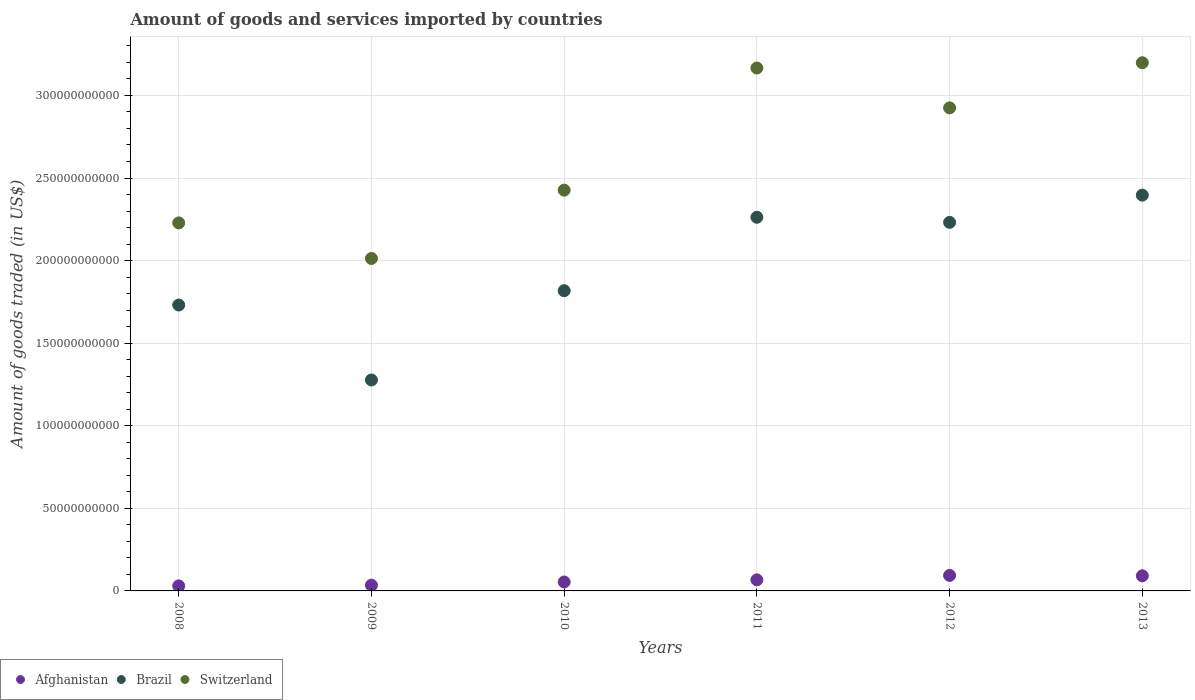Is the number of dotlines equal to the number of legend labels?
Offer a very short reply. Yes. What is the total amount of goods and services imported in Switzerland in 2013?
Provide a short and direct response. 3.20e+11. Across all years, what is the maximum total amount of goods and services imported in Brazil?
Offer a terse response. 2.40e+11. Across all years, what is the minimum total amount of goods and services imported in Brazil?
Make the answer very short. 1.28e+11. In which year was the total amount of goods and services imported in Afghanistan maximum?
Keep it short and to the point. 2012. In which year was the total amount of goods and services imported in Switzerland minimum?
Offer a terse response. 2009. What is the total total amount of goods and services imported in Brazil in the graph?
Your response must be concise. 1.17e+12. What is the difference between the total amount of goods and services imported in Afghanistan in 2009 and that in 2011?
Your answer should be very brief. -3.24e+09. What is the difference between the total amount of goods and services imported in Afghanistan in 2011 and the total amount of goods and services imported in Switzerland in 2008?
Give a very brief answer. -2.16e+11. What is the average total amount of goods and services imported in Switzerland per year?
Keep it short and to the point. 2.66e+11. In the year 2009, what is the difference between the total amount of goods and services imported in Switzerland and total amount of goods and services imported in Afghanistan?
Provide a short and direct response. 1.98e+11. In how many years, is the total amount of goods and services imported in Switzerland greater than 130000000000 US$?
Provide a succinct answer. 6. What is the ratio of the total amount of goods and services imported in Afghanistan in 2008 to that in 2013?
Make the answer very short. 0.33. Is the total amount of goods and services imported in Afghanistan in 2010 less than that in 2012?
Make the answer very short. Yes. Is the difference between the total amount of goods and services imported in Switzerland in 2009 and 2013 greater than the difference between the total amount of goods and services imported in Afghanistan in 2009 and 2013?
Your answer should be compact. No. What is the difference between the highest and the second highest total amount of goods and services imported in Brazil?
Ensure brevity in your answer.  1.34e+1. What is the difference between the highest and the lowest total amount of goods and services imported in Afghanistan?
Offer a very short reply. 6.35e+09. Is the sum of the total amount of goods and services imported in Afghanistan in 2009 and 2013 greater than the maximum total amount of goods and services imported in Brazil across all years?
Your response must be concise. No. Does the total amount of goods and services imported in Afghanistan monotonically increase over the years?
Your answer should be very brief. No. How many dotlines are there?
Give a very brief answer. 3. How many years are there in the graph?
Keep it short and to the point. 6. Does the graph contain any zero values?
Offer a very short reply. No. How many legend labels are there?
Offer a very short reply. 3. How are the legend labels stacked?
Provide a short and direct response. Horizontal. What is the title of the graph?
Your response must be concise. Amount of goods and services imported by countries. What is the label or title of the X-axis?
Make the answer very short. Years. What is the label or title of the Y-axis?
Make the answer very short. Amount of goods traded (in US$). What is the Amount of goods traded (in US$) in Afghanistan in 2008?
Provide a succinct answer. 3.04e+09. What is the Amount of goods traded (in US$) in Brazil in 2008?
Your answer should be compact. 1.73e+11. What is the Amount of goods traded (in US$) in Switzerland in 2008?
Offer a terse response. 2.23e+11. What is the Amount of goods traded (in US$) of Afghanistan in 2009?
Ensure brevity in your answer.  3.47e+09. What is the Amount of goods traded (in US$) of Brazil in 2009?
Make the answer very short. 1.28e+11. What is the Amount of goods traded (in US$) in Switzerland in 2009?
Your answer should be very brief. 2.01e+11. What is the Amount of goods traded (in US$) of Afghanistan in 2010?
Provide a succinct answer. 5.40e+09. What is the Amount of goods traded (in US$) in Brazil in 2010?
Offer a very short reply. 1.82e+11. What is the Amount of goods traded (in US$) in Switzerland in 2010?
Keep it short and to the point. 2.43e+11. What is the Amount of goods traded (in US$) in Afghanistan in 2011?
Provide a succinct answer. 6.71e+09. What is the Amount of goods traded (in US$) in Brazil in 2011?
Keep it short and to the point. 2.26e+11. What is the Amount of goods traded (in US$) of Switzerland in 2011?
Provide a succinct answer. 3.17e+11. What is the Amount of goods traded (in US$) in Afghanistan in 2012?
Your answer should be compact. 9.39e+09. What is the Amount of goods traded (in US$) of Brazil in 2012?
Keep it short and to the point. 2.23e+11. What is the Amount of goods traded (in US$) in Switzerland in 2012?
Provide a short and direct response. 2.92e+11. What is the Amount of goods traded (in US$) of Afghanistan in 2013?
Your answer should be compact. 9.15e+09. What is the Amount of goods traded (in US$) of Brazil in 2013?
Make the answer very short. 2.40e+11. What is the Amount of goods traded (in US$) of Switzerland in 2013?
Make the answer very short. 3.20e+11. Across all years, what is the maximum Amount of goods traded (in US$) in Afghanistan?
Give a very brief answer. 9.39e+09. Across all years, what is the maximum Amount of goods traded (in US$) in Brazil?
Give a very brief answer. 2.40e+11. Across all years, what is the maximum Amount of goods traded (in US$) in Switzerland?
Keep it short and to the point. 3.20e+11. Across all years, what is the minimum Amount of goods traded (in US$) in Afghanistan?
Offer a terse response. 3.04e+09. Across all years, what is the minimum Amount of goods traded (in US$) of Brazil?
Provide a short and direct response. 1.28e+11. Across all years, what is the minimum Amount of goods traded (in US$) in Switzerland?
Ensure brevity in your answer.  2.01e+11. What is the total Amount of goods traded (in US$) in Afghanistan in the graph?
Keep it short and to the point. 3.72e+1. What is the total Amount of goods traded (in US$) in Brazil in the graph?
Offer a terse response. 1.17e+12. What is the total Amount of goods traded (in US$) in Switzerland in the graph?
Offer a terse response. 1.60e+12. What is the difference between the Amount of goods traded (in US$) in Afghanistan in 2008 and that in 2009?
Provide a succinct answer. -4.23e+08. What is the difference between the Amount of goods traded (in US$) in Brazil in 2008 and that in 2009?
Offer a terse response. 4.54e+1. What is the difference between the Amount of goods traded (in US$) of Switzerland in 2008 and that in 2009?
Make the answer very short. 2.15e+1. What is the difference between the Amount of goods traded (in US$) of Afghanistan in 2008 and that in 2010?
Give a very brief answer. -2.36e+09. What is the difference between the Amount of goods traded (in US$) in Brazil in 2008 and that in 2010?
Your answer should be compact. -8.66e+09. What is the difference between the Amount of goods traded (in US$) of Switzerland in 2008 and that in 2010?
Ensure brevity in your answer.  -1.98e+1. What is the difference between the Amount of goods traded (in US$) of Afghanistan in 2008 and that in 2011?
Your response must be concise. -3.67e+09. What is the difference between the Amount of goods traded (in US$) of Brazil in 2008 and that in 2011?
Provide a short and direct response. -5.31e+1. What is the difference between the Amount of goods traded (in US$) in Switzerland in 2008 and that in 2011?
Offer a terse response. -9.38e+1. What is the difference between the Amount of goods traded (in US$) in Afghanistan in 2008 and that in 2012?
Keep it short and to the point. -6.35e+09. What is the difference between the Amount of goods traded (in US$) of Brazil in 2008 and that in 2012?
Offer a terse response. -5.00e+1. What is the difference between the Amount of goods traded (in US$) of Switzerland in 2008 and that in 2012?
Ensure brevity in your answer.  -6.96e+1. What is the difference between the Amount of goods traded (in US$) of Afghanistan in 2008 and that in 2013?
Keep it short and to the point. -6.10e+09. What is the difference between the Amount of goods traded (in US$) in Brazil in 2008 and that in 2013?
Your answer should be compact. -6.65e+1. What is the difference between the Amount of goods traded (in US$) of Switzerland in 2008 and that in 2013?
Keep it short and to the point. -9.70e+1. What is the difference between the Amount of goods traded (in US$) of Afghanistan in 2009 and that in 2010?
Make the answer very short. -1.94e+09. What is the difference between the Amount of goods traded (in US$) of Brazil in 2009 and that in 2010?
Your response must be concise. -5.40e+1. What is the difference between the Amount of goods traded (in US$) of Switzerland in 2009 and that in 2010?
Ensure brevity in your answer.  -4.14e+1. What is the difference between the Amount of goods traded (in US$) in Afghanistan in 2009 and that in 2011?
Offer a terse response. -3.24e+09. What is the difference between the Amount of goods traded (in US$) of Brazil in 2009 and that in 2011?
Your response must be concise. -9.85e+1. What is the difference between the Amount of goods traded (in US$) in Switzerland in 2009 and that in 2011?
Your response must be concise. -1.15e+11. What is the difference between the Amount of goods traded (in US$) of Afghanistan in 2009 and that in 2012?
Your answer should be very brief. -5.93e+09. What is the difference between the Amount of goods traded (in US$) of Brazil in 2009 and that in 2012?
Give a very brief answer. -9.54e+1. What is the difference between the Amount of goods traded (in US$) of Switzerland in 2009 and that in 2012?
Ensure brevity in your answer.  -9.12e+1. What is the difference between the Amount of goods traded (in US$) of Afghanistan in 2009 and that in 2013?
Your response must be concise. -5.68e+09. What is the difference between the Amount of goods traded (in US$) of Brazil in 2009 and that in 2013?
Your answer should be compact. -1.12e+11. What is the difference between the Amount of goods traded (in US$) in Switzerland in 2009 and that in 2013?
Your answer should be compact. -1.19e+11. What is the difference between the Amount of goods traded (in US$) of Afghanistan in 2010 and that in 2011?
Keep it short and to the point. -1.31e+09. What is the difference between the Amount of goods traded (in US$) of Brazil in 2010 and that in 2011?
Your response must be concise. -4.45e+1. What is the difference between the Amount of goods traded (in US$) in Switzerland in 2010 and that in 2011?
Keep it short and to the point. -7.39e+1. What is the difference between the Amount of goods traded (in US$) of Afghanistan in 2010 and that in 2012?
Your answer should be very brief. -3.99e+09. What is the difference between the Amount of goods traded (in US$) in Brazil in 2010 and that in 2012?
Give a very brief answer. -4.14e+1. What is the difference between the Amount of goods traded (in US$) in Switzerland in 2010 and that in 2012?
Make the answer very short. -4.98e+1. What is the difference between the Amount of goods traded (in US$) of Afghanistan in 2010 and that in 2013?
Provide a short and direct response. -3.75e+09. What is the difference between the Amount of goods traded (in US$) of Brazil in 2010 and that in 2013?
Give a very brief answer. -5.79e+1. What is the difference between the Amount of goods traded (in US$) of Switzerland in 2010 and that in 2013?
Give a very brief answer. -7.71e+1. What is the difference between the Amount of goods traded (in US$) in Afghanistan in 2011 and that in 2012?
Keep it short and to the point. -2.68e+09. What is the difference between the Amount of goods traded (in US$) of Brazil in 2011 and that in 2012?
Give a very brief answer. 3.08e+09. What is the difference between the Amount of goods traded (in US$) of Switzerland in 2011 and that in 2012?
Provide a succinct answer. 2.41e+1. What is the difference between the Amount of goods traded (in US$) of Afghanistan in 2011 and that in 2013?
Your answer should be very brief. -2.44e+09. What is the difference between the Amount of goods traded (in US$) of Brazil in 2011 and that in 2013?
Your answer should be very brief. -1.34e+1. What is the difference between the Amount of goods traded (in US$) in Switzerland in 2011 and that in 2013?
Offer a very short reply. -3.21e+09. What is the difference between the Amount of goods traded (in US$) of Afghanistan in 2012 and that in 2013?
Your answer should be very brief. 2.47e+08. What is the difference between the Amount of goods traded (in US$) in Brazil in 2012 and that in 2013?
Keep it short and to the point. -1.65e+1. What is the difference between the Amount of goods traded (in US$) in Switzerland in 2012 and that in 2013?
Provide a succinct answer. -2.73e+1. What is the difference between the Amount of goods traded (in US$) in Afghanistan in 2008 and the Amount of goods traded (in US$) in Brazil in 2009?
Ensure brevity in your answer.  -1.25e+11. What is the difference between the Amount of goods traded (in US$) of Afghanistan in 2008 and the Amount of goods traded (in US$) of Switzerland in 2009?
Your answer should be very brief. -1.98e+11. What is the difference between the Amount of goods traded (in US$) of Brazil in 2008 and the Amount of goods traded (in US$) of Switzerland in 2009?
Your answer should be very brief. -2.82e+1. What is the difference between the Amount of goods traded (in US$) of Afghanistan in 2008 and the Amount of goods traded (in US$) of Brazil in 2010?
Offer a terse response. -1.79e+11. What is the difference between the Amount of goods traded (in US$) in Afghanistan in 2008 and the Amount of goods traded (in US$) in Switzerland in 2010?
Provide a short and direct response. -2.40e+11. What is the difference between the Amount of goods traded (in US$) of Brazil in 2008 and the Amount of goods traded (in US$) of Switzerland in 2010?
Make the answer very short. -6.95e+1. What is the difference between the Amount of goods traded (in US$) in Afghanistan in 2008 and the Amount of goods traded (in US$) in Brazil in 2011?
Give a very brief answer. -2.23e+11. What is the difference between the Amount of goods traded (in US$) of Afghanistan in 2008 and the Amount of goods traded (in US$) of Switzerland in 2011?
Offer a very short reply. -3.14e+11. What is the difference between the Amount of goods traded (in US$) in Brazil in 2008 and the Amount of goods traded (in US$) in Switzerland in 2011?
Provide a short and direct response. -1.43e+11. What is the difference between the Amount of goods traded (in US$) in Afghanistan in 2008 and the Amount of goods traded (in US$) in Brazil in 2012?
Offer a terse response. -2.20e+11. What is the difference between the Amount of goods traded (in US$) of Afghanistan in 2008 and the Amount of goods traded (in US$) of Switzerland in 2012?
Make the answer very short. -2.89e+11. What is the difference between the Amount of goods traded (in US$) in Brazil in 2008 and the Amount of goods traded (in US$) in Switzerland in 2012?
Offer a very short reply. -1.19e+11. What is the difference between the Amount of goods traded (in US$) in Afghanistan in 2008 and the Amount of goods traded (in US$) in Brazil in 2013?
Your answer should be very brief. -2.37e+11. What is the difference between the Amount of goods traded (in US$) of Afghanistan in 2008 and the Amount of goods traded (in US$) of Switzerland in 2013?
Your response must be concise. -3.17e+11. What is the difference between the Amount of goods traded (in US$) in Brazil in 2008 and the Amount of goods traded (in US$) in Switzerland in 2013?
Give a very brief answer. -1.47e+11. What is the difference between the Amount of goods traded (in US$) in Afghanistan in 2009 and the Amount of goods traded (in US$) in Brazil in 2010?
Make the answer very short. -1.78e+11. What is the difference between the Amount of goods traded (in US$) in Afghanistan in 2009 and the Amount of goods traded (in US$) in Switzerland in 2010?
Your answer should be compact. -2.39e+11. What is the difference between the Amount of goods traded (in US$) in Brazil in 2009 and the Amount of goods traded (in US$) in Switzerland in 2010?
Make the answer very short. -1.15e+11. What is the difference between the Amount of goods traded (in US$) in Afghanistan in 2009 and the Amount of goods traded (in US$) in Brazil in 2011?
Give a very brief answer. -2.23e+11. What is the difference between the Amount of goods traded (in US$) in Afghanistan in 2009 and the Amount of goods traded (in US$) in Switzerland in 2011?
Keep it short and to the point. -3.13e+11. What is the difference between the Amount of goods traded (in US$) of Brazil in 2009 and the Amount of goods traded (in US$) of Switzerland in 2011?
Make the answer very short. -1.89e+11. What is the difference between the Amount of goods traded (in US$) of Afghanistan in 2009 and the Amount of goods traded (in US$) of Brazil in 2012?
Your response must be concise. -2.20e+11. What is the difference between the Amount of goods traded (in US$) of Afghanistan in 2009 and the Amount of goods traded (in US$) of Switzerland in 2012?
Your answer should be very brief. -2.89e+11. What is the difference between the Amount of goods traded (in US$) in Brazil in 2009 and the Amount of goods traded (in US$) in Switzerland in 2012?
Provide a succinct answer. -1.65e+11. What is the difference between the Amount of goods traded (in US$) in Afghanistan in 2009 and the Amount of goods traded (in US$) in Brazil in 2013?
Keep it short and to the point. -2.36e+11. What is the difference between the Amount of goods traded (in US$) in Afghanistan in 2009 and the Amount of goods traded (in US$) in Switzerland in 2013?
Provide a succinct answer. -3.16e+11. What is the difference between the Amount of goods traded (in US$) in Brazil in 2009 and the Amount of goods traded (in US$) in Switzerland in 2013?
Provide a short and direct response. -1.92e+11. What is the difference between the Amount of goods traded (in US$) of Afghanistan in 2010 and the Amount of goods traded (in US$) of Brazil in 2011?
Provide a short and direct response. -2.21e+11. What is the difference between the Amount of goods traded (in US$) in Afghanistan in 2010 and the Amount of goods traded (in US$) in Switzerland in 2011?
Provide a short and direct response. -3.11e+11. What is the difference between the Amount of goods traded (in US$) in Brazil in 2010 and the Amount of goods traded (in US$) in Switzerland in 2011?
Provide a short and direct response. -1.35e+11. What is the difference between the Amount of goods traded (in US$) in Afghanistan in 2010 and the Amount of goods traded (in US$) in Brazil in 2012?
Offer a very short reply. -2.18e+11. What is the difference between the Amount of goods traded (in US$) in Afghanistan in 2010 and the Amount of goods traded (in US$) in Switzerland in 2012?
Give a very brief answer. -2.87e+11. What is the difference between the Amount of goods traded (in US$) of Brazil in 2010 and the Amount of goods traded (in US$) of Switzerland in 2012?
Your answer should be very brief. -1.11e+11. What is the difference between the Amount of goods traded (in US$) in Afghanistan in 2010 and the Amount of goods traded (in US$) in Brazil in 2013?
Your answer should be very brief. -2.34e+11. What is the difference between the Amount of goods traded (in US$) of Afghanistan in 2010 and the Amount of goods traded (in US$) of Switzerland in 2013?
Ensure brevity in your answer.  -3.14e+11. What is the difference between the Amount of goods traded (in US$) of Brazil in 2010 and the Amount of goods traded (in US$) of Switzerland in 2013?
Offer a terse response. -1.38e+11. What is the difference between the Amount of goods traded (in US$) in Afghanistan in 2011 and the Amount of goods traded (in US$) in Brazil in 2012?
Your answer should be very brief. -2.16e+11. What is the difference between the Amount of goods traded (in US$) of Afghanistan in 2011 and the Amount of goods traded (in US$) of Switzerland in 2012?
Provide a short and direct response. -2.86e+11. What is the difference between the Amount of goods traded (in US$) of Brazil in 2011 and the Amount of goods traded (in US$) of Switzerland in 2012?
Provide a short and direct response. -6.62e+1. What is the difference between the Amount of goods traded (in US$) in Afghanistan in 2011 and the Amount of goods traded (in US$) in Brazil in 2013?
Provide a succinct answer. -2.33e+11. What is the difference between the Amount of goods traded (in US$) in Afghanistan in 2011 and the Amount of goods traded (in US$) in Switzerland in 2013?
Your answer should be very brief. -3.13e+11. What is the difference between the Amount of goods traded (in US$) of Brazil in 2011 and the Amount of goods traded (in US$) of Switzerland in 2013?
Your answer should be very brief. -9.36e+1. What is the difference between the Amount of goods traded (in US$) in Afghanistan in 2012 and the Amount of goods traded (in US$) in Brazil in 2013?
Give a very brief answer. -2.30e+11. What is the difference between the Amount of goods traded (in US$) in Afghanistan in 2012 and the Amount of goods traded (in US$) in Switzerland in 2013?
Make the answer very short. -3.10e+11. What is the difference between the Amount of goods traded (in US$) in Brazil in 2012 and the Amount of goods traded (in US$) in Switzerland in 2013?
Ensure brevity in your answer.  -9.66e+1. What is the average Amount of goods traded (in US$) in Afghanistan per year?
Make the answer very short. 6.19e+09. What is the average Amount of goods traded (in US$) of Brazil per year?
Offer a very short reply. 1.95e+11. What is the average Amount of goods traded (in US$) in Switzerland per year?
Provide a succinct answer. 2.66e+11. In the year 2008, what is the difference between the Amount of goods traded (in US$) of Afghanistan and Amount of goods traded (in US$) of Brazil?
Give a very brief answer. -1.70e+11. In the year 2008, what is the difference between the Amount of goods traded (in US$) of Afghanistan and Amount of goods traded (in US$) of Switzerland?
Make the answer very short. -2.20e+11. In the year 2008, what is the difference between the Amount of goods traded (in US$) of Brazil and Amount of goods traded (in US$) of Switzerland?
Make the answer very short. -4.97e+1. In the year 2009, what is the difference between the Amount of goods traded (in US$) of Afghanistan and Amount of goods traded (in US$) of Brazil?
Provide a short and direct response. -1.24e+11. In the year 2009, what is the difference between the Amount of goods traded (in US$) in Afghanistan and Amount of goods traded (in US$) in Switzerland?
Give a very brief answer. -1.98e+11. In the year 2009, what is the difference between the Amount of goods traded (in US$) in Brazil and Amount of goods traded (in US$) in Switzerland?
Give a very brief answer. -7.36e+1. In the year 2010, what is the difference between the Amount of goods traded (in US$) in Afghanistan and Amount of goods traded (in US$) in Brazil?
Offer a very short reply. -1.76e+11. In the year 2010, what is the difference between the Amount of goods traded (in US$) of Afghanistan and Amount of goods traded (in US$) of Switzerland?
Your answer should be compact. -2.37e+11. In the year 2010, what is the difference between the Amount of goods traded (in US$) in Brazil and Amount of goods traded (in US$) in Switzerland?
Make the answer very short. -6.09e+1. In the year 2011, what is the difference between the Amount of goods traded (in US$) in Afghanistan and Amount of goods traded (in US$) in Brazil?
Make the answer very short. -2.20e+11. In the year 2011, what is the difference between the Amount of goods traded (in US$) in Afghanistan and Amount of goods traded (in US$) in Switzerland?
Keep it short and to the point. -3.10e+11. In the year 2011, what is the difference between the Amount of goods traded (in US$) of Brazil and Amount of goods traded (in US$) of Switzerland?
Your answer should be very brief. -9.04e+1. In the year 2012, what is the difference between the Amount of goods traded (in US$) in Afghanistan and Amount of goods traded (in US$) in Brazil?
Ensure brevity in your answer.  -2.14e+11. In the year 2012, what is the difference between the Amount of goods traded (in US$) in Afghanistan and Amount of goods traded (in US$) in Switzerland?
Ensure brevity in your answer.  -2.83e+11. In the year 2012, what is the difference between the Amount of goods traded (in US$) of Brazil and Amount of goods traded (in US$) of Switzerland?
Your answer should be very brief. -6.93e+1. In the year 2013, what is the difference between the Amount of goods traded (in US$) of Afghanistan and Amount of goods traded (in US$) of Brazil?
Ensure brevity in your answer.  -2.30e+11. In the year 2013, what is the difference between the Amount of goods traded (in US$) in Afghanistan and Amount of goods traded (in US$) in Switzerland?
Your answer should be very brief. -3.11e+11. In the year 2013, what is the difference between the Amount of goods traded (in US$) of Brazil and Amount of goods traded (in US$) of Switzerland?
Offer a terse response. -8.02e+1. What is the ratio of the Amount of goods traded (in US$) in Afghanistan in 2008 to that in 2009?
Offer a terse response. 0.88. What is the ratio of the Amount of goods traded (in US$) in Brazil in 2008 to that in 2009?
Provide a succinct answer. 1.36. What is the ratio of the Amount of goods traded (in US$) of Switzerland in 2008 to that in 2009?
Your response must be concise. 1.11. What is the ratio of the Amount of goods traded (in US$) of Afghanistan in 2008 to that in 2010?
Keep it short and to the point. 0.56. What is the ratio of the Amount of goods traded (in US$) in Switzerland in 2008 to that in 2010?
Make the answer very short. 0.92. What is the ratio of the Amount of goods traded (in US$) of Afghanistan in 2008 to that in 2011?
Make the answer very short. 0.45. What is the ratio of the Amount of goods traded (in US$) in Brazil in 2008 to that in 2011?
Ensure brevity in your answer.  0.77. What is the ratio of the Amount of goods traded (in US$) in Switzerland in 2008 to that in 2011?
Your answer should be compact. 0.7. What is the ratio of the Amount of goods traded (in US$) of Afghanistan in 2008 to that in 2012?
Give a very brief answer. 0.32. What is the ratio of the Amount of goods traded (in US$) of Brazil in 2008 to that in 2012?
Offer a very short reply. 0.78. What is the ratio of the Amount of goods traded (in US$) in Switzerland in 2008 to that in 2012?
Your answer should be compact. 0.76. What is the ratio of the Amount of goods traded (in US$) of Afghanistan in 2008 to that in 2013?
Offer a very short reply. 0.33. What is the ratio of the Amount of goods traded (in US$) of Brazil in 2008 to that in 2013?
Make the answer very short. 0.72. What is the ratio of the Amount of goods traded (in US$) of Switzerland in 2008 to that in 2013?
Make the answer very short. 0.7. What is the ratio of the Amount of goods traded (in US$) of Afghanistan in 2009 to that in 2010?
Offer a very short reply. 0.64. What is the ratio of the Amount of goods traded (in US$) in Brazil in 2009 to that in 2010?
Make the answer very short. 0.7. What is the ratio of the Amount of goods traded (in US$) of Switzerland in 2009 to that in 2010?
Provide a succinct answer. 0.83. What is the ratio of the Amount of goods traded (in US$) in Afghanistan in 2009 to that in 2011?
Give a very brief answer. 0.52. What is the ratio of the Amount of goods traded (in US$) of Brazil in 2009 to that in 2011?
Offer a terse response. 0.56. What is the ratio of the Amount of goods traded (in US$) in Switzerland in 2009 to that in 2011?
Provide a short and direct response. 0.64. What is the ratio of the Amount of goods traded (in US$) in Afghanistan in 2009 to that in 2012?
Ensure brevity in your answer.  0.37. What is the ratio of the Amount of goods traded (in US$) of Brazil in 2009 to that in 2012?
Offer a very short reply. 0.57. What is the ratio of the Amount of goods traded (in US$) of Switzerland in 2009 to that in 2012?
Provide a succinct answer. 0.69. What is the ratio of the Amount of goods traded (in US$) of Afghanistan in 2009 to that in 2013?
Give a very brief answer. 0.38. What is the ratio of the Amount of goods traded (in US$) of Brazil in 2009 to that in 2013?
Keep it short and to the point. 0.53. What is the ratio of the Amount of goods traded (in US$) in Switzerland in 2009 to that in 2013?
Provide a short and direct response. 0.63. What is the ratio of the Amount of goods traded (in US$) of Afghanistan in 2010 to that in 2011?
Offer a very short reply. 0.8. What is the ratio of the Amount of goods traded (in US$) of Brazil in 2010 to that in 2011?
Provide a succinct answer. 0.8. What is the ratio of the Amount of goods traded (in US$) of Switzerland in 2010 to that in 2011?
Your answer should be compact. 0.77. What is the ratio of the Amount of goods traded (in US$) in Afghanistan in 2010 to that in 2012?
Your answer should be very brief. 0.57. What is the ratio of the Amount of goods traded (in US$) in Brazil in 2010 to that in 2012?
Keep it short and to the point. 0.81. What is the ratio of the Amount of goods traded (in US$) of Switzerland in 2010 to that in 2012?
Offer a terse response. 0.83. What is the ratio of the Amount of goods traded (in US$) of Afghanistan in 2010 to that in 2013?
Provide a succinct answer. 0.59. What is the ratio of the Amount of goods traded (in US$) in Brazil in 2010 to that in 2013?
Your answer should be compact. 0.76. What is the ratio of the Amount of goods traded (in US$) in Switzerland in 2010 to that in 2013?
Your answer should be compact. 0.76. What is the ratio of the Amount of goods traded (in US$) of Afghanistan in 2011 to that in 2012?
Offer a very short reply. 0.71. What is the ratio of the Amount of goods traded (in US$) in Brazil in 2011 to that in 2012?
Your answer should be very brief. 1.01. What is the ratio of the Amount of goods traded (in US$) of Switzerland in 2011 to that in 2012?
Make the answer very short. 1.08. What is the ratio of the Amount of goods traded (in US$) of Afghanistan in 2011 to that in 2013?
Give a very brief answer. 0.73. What is the ratio of the Amount of goods traded (in US$) of Brazil in 2011 to that in 2013?
Your answer should be very brief. 0.94. What is the ratio of the Amount of goods traded (in US$) in Switzerland in 2011 to that in 2013?
Offer a very short reply. 0.99. What is the ratio of the Amount of goods traded (in US$) of Afghanistan in 2012 to that in 2013?
Ensure brevity in your answer.  1.03. What is the ratio of the Amount of goods traded (in US$) of Brazil in 2012 to that in 2013?
Make the answer very short. 0.93. What is the ratio of the Amount of goods traded (in US$) of Switzerland in 2012 to that in 2013?
Ensure brevity in your answer.  0.91. What is the difference between the highest and the second highest Amount of goods traded (in US$) of Afghanistan?
Ensure brevity in your answer.  2.47e+08. What is the difference between the highest and the second highest Amount of goods traded (in US$) of Brazil?
Ensure brevity in your answer.  1.34e+1. What is the difference between the highest and the second highest Amount of goods traded (in US$) of Switzerland?
Provide a succinct answer. 3.21e+09. What is the difference between the highest and the lowest Amount of goods traded (in US$) of Afghanistan?
Give a very brief answer. 6.35e+09. What is the difference between the highest and the lowest Amount of goods traded (in US$) of Brazil?
Your response must be concise. 1.12e+11. What is the difference between the highest and the lowest Amount of goods traded (in US$) of Switzerland?
Your answer should be very brief. 1.19e+11. 